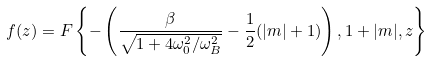<formula> <loc_0><loc_0><loc_500><loc_500>f ( z ) = F \left \{ - \left ( \frac { \beta } { \sqrt { 1 + 4 \omega _ { 0 } ^ { 2 } / \omega _ { B } ^ { 2 } } } - \frac { 1 } { 2 } ( | m | + 1 ) \right ) , 1 + | m | , z \right \}</formula> 